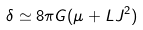<formula> <loc_0><loc_0><loc_500><loc_500>\delta \simeq 8 \pi G ( \mu + L J ^ { 2 } )</formula> 